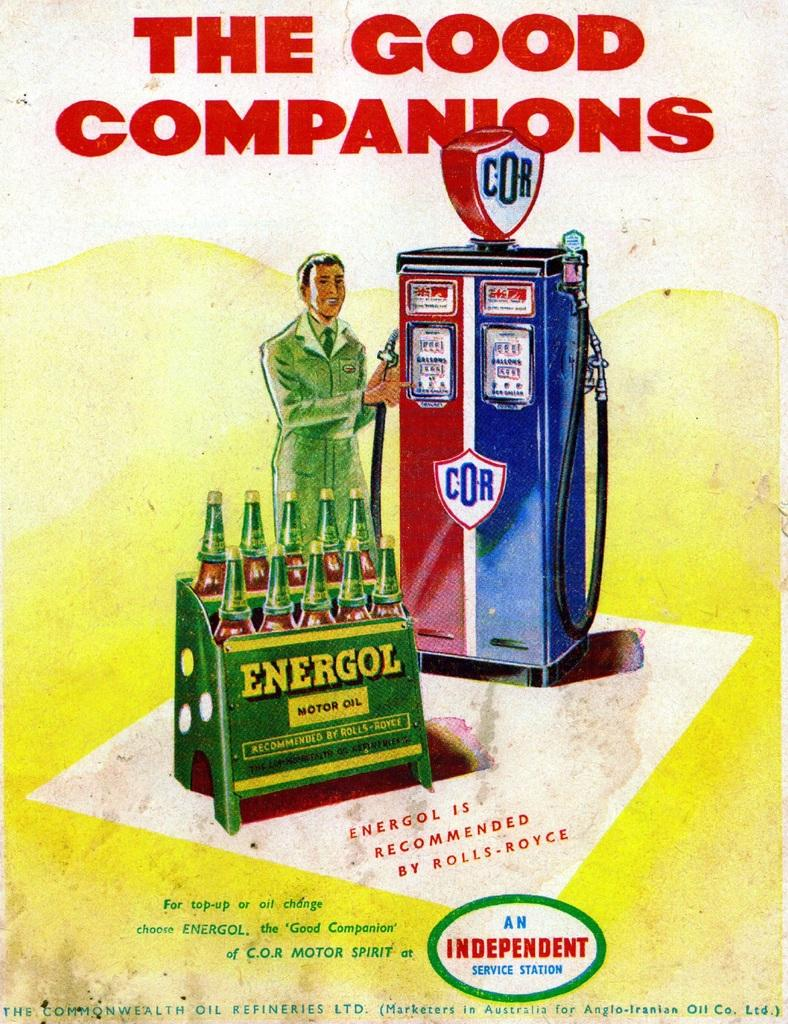Provide a one-sentence caption for the provided image. The flyer advertises Energol motor oil which isn't around anymore. 